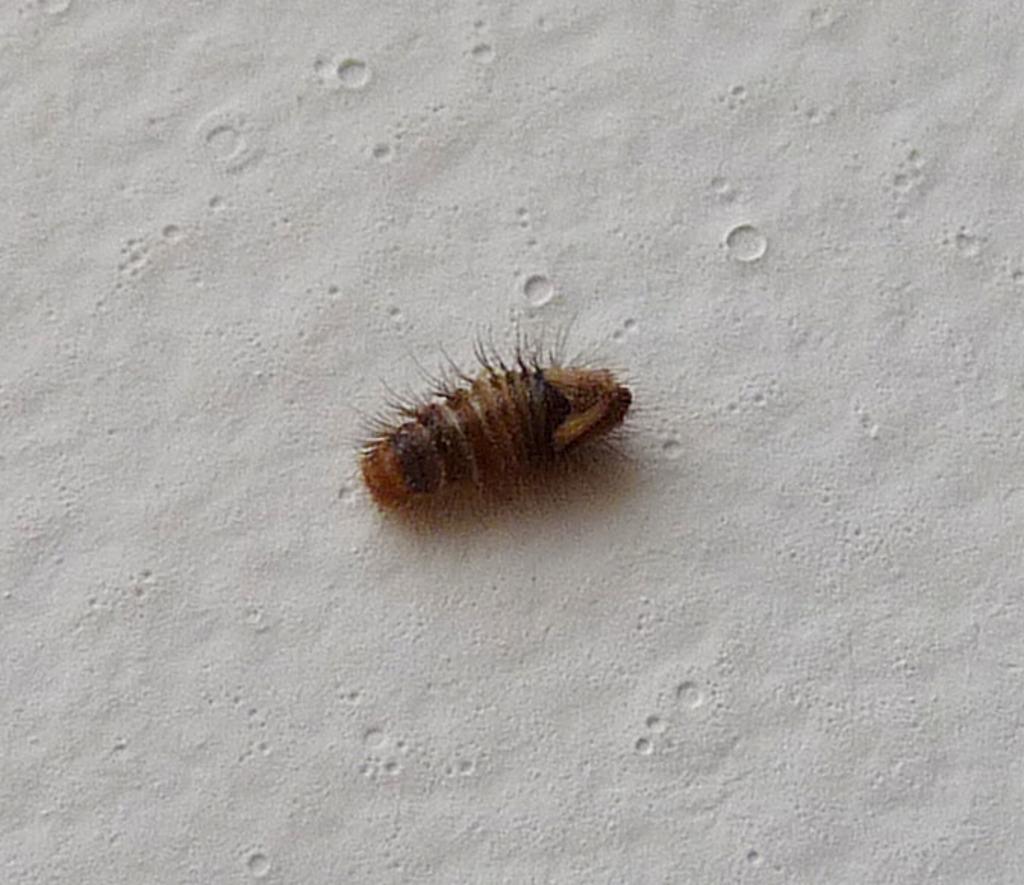In one or two sentences, can you explain what this image depicts? In this image we can see an insect on the ground. 